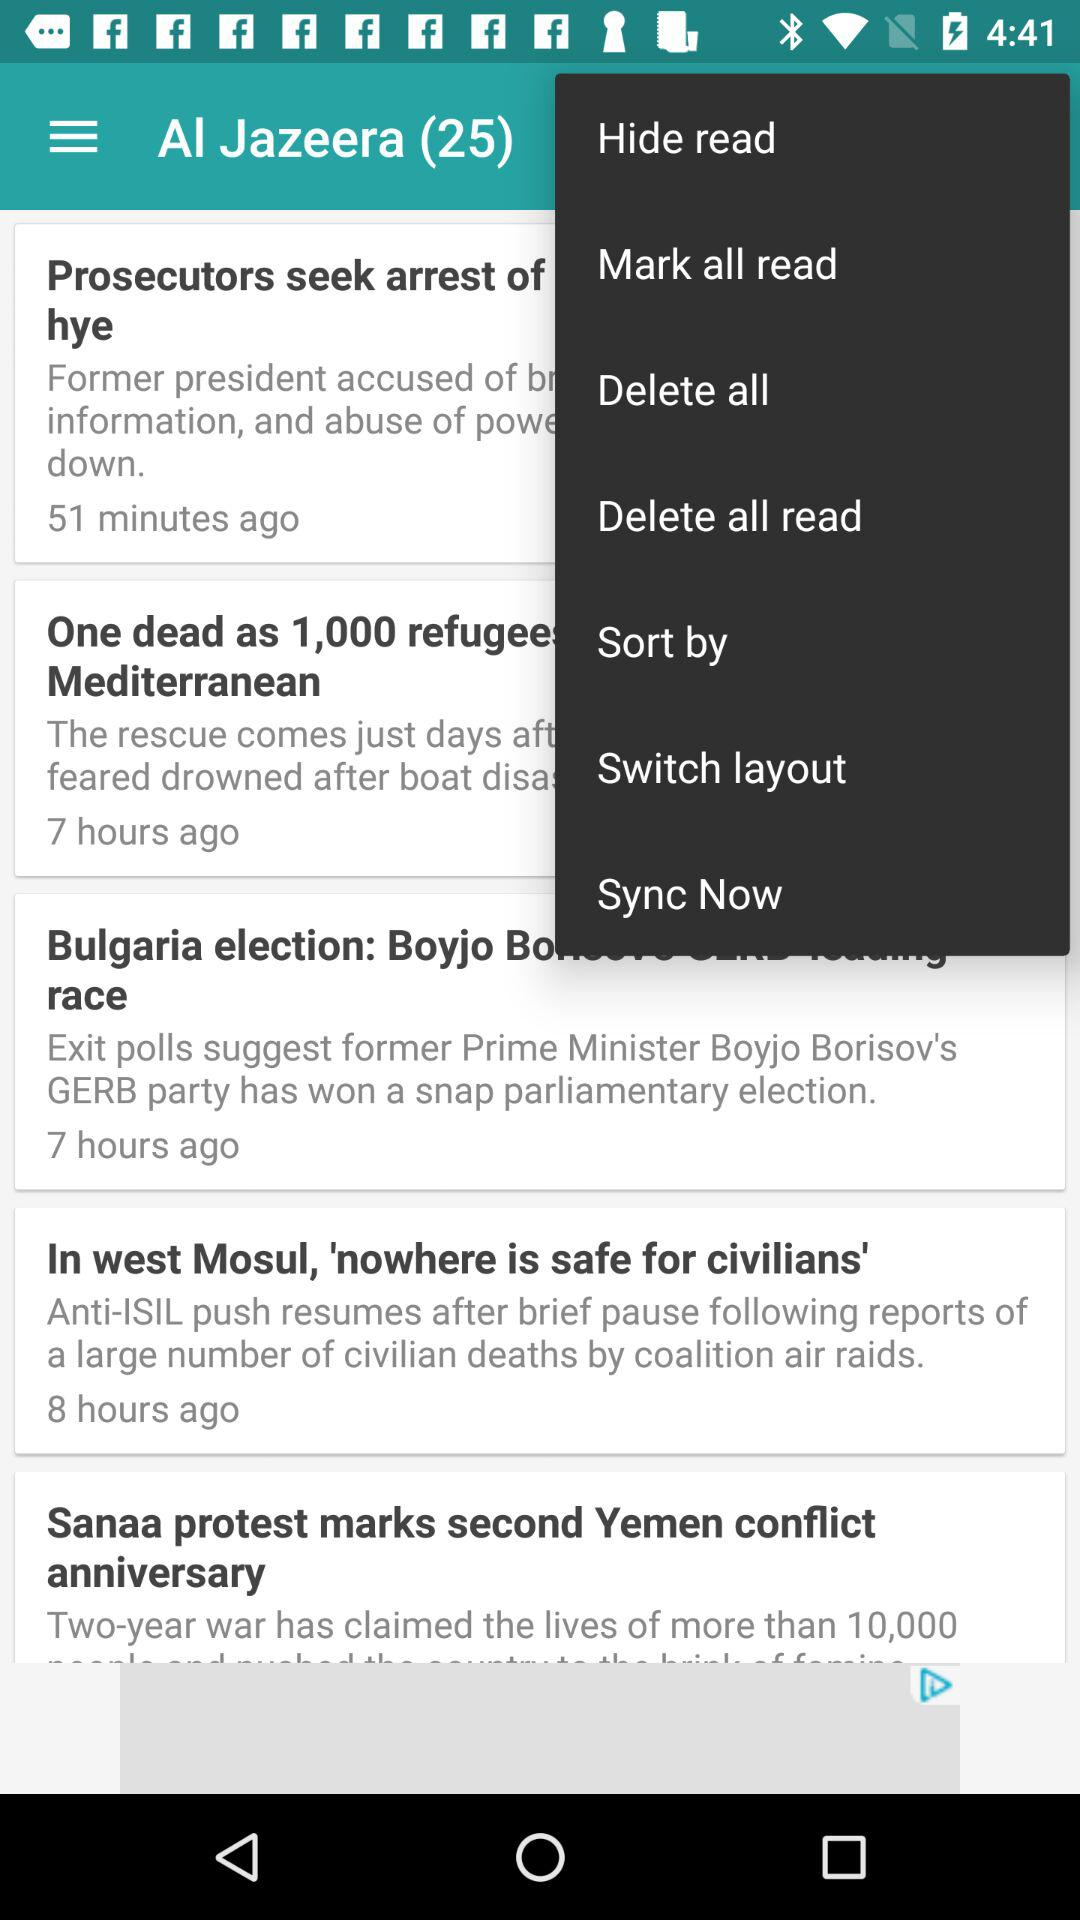What is the name of the application? The name of the application is "Al Jazeera". 